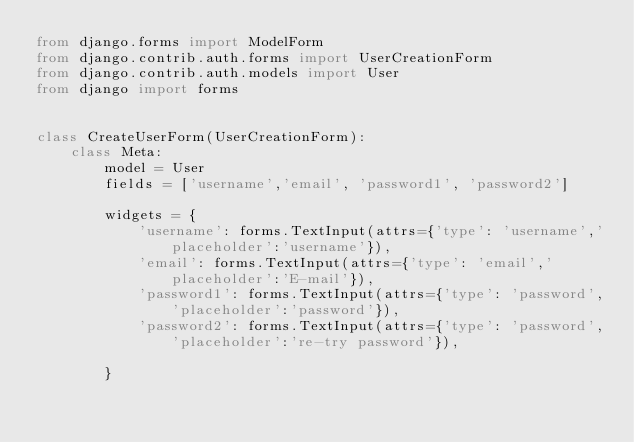Convert code to text. <code><loc_0><loc_0><loc_500><loc_500><_Python_>from django.forms import ModelForm
from django.contrib.auth.forms import UserCreationForm
from django.contrib.auth.models import User
from django import forms


class CreateUserForm(UserCreationForm):
    class Meta:
        model = User
        fields = ['username','email', 'password1', 'password2']

        widgets = {
            'username': forms.TextInput(attrs={'type': 'username','placeholder':'username'}),
            'email': forms.TextInput(attrs={'type': 'email','placeholder':'E-mail'}),
            'password1': forms.TextInput(attrs={'type': 'password','placeholder':'password'}),
            'password2': forms.TextInput(attrs={'type': 'password','placeholder':'re-try password'}),

        }
</code> 